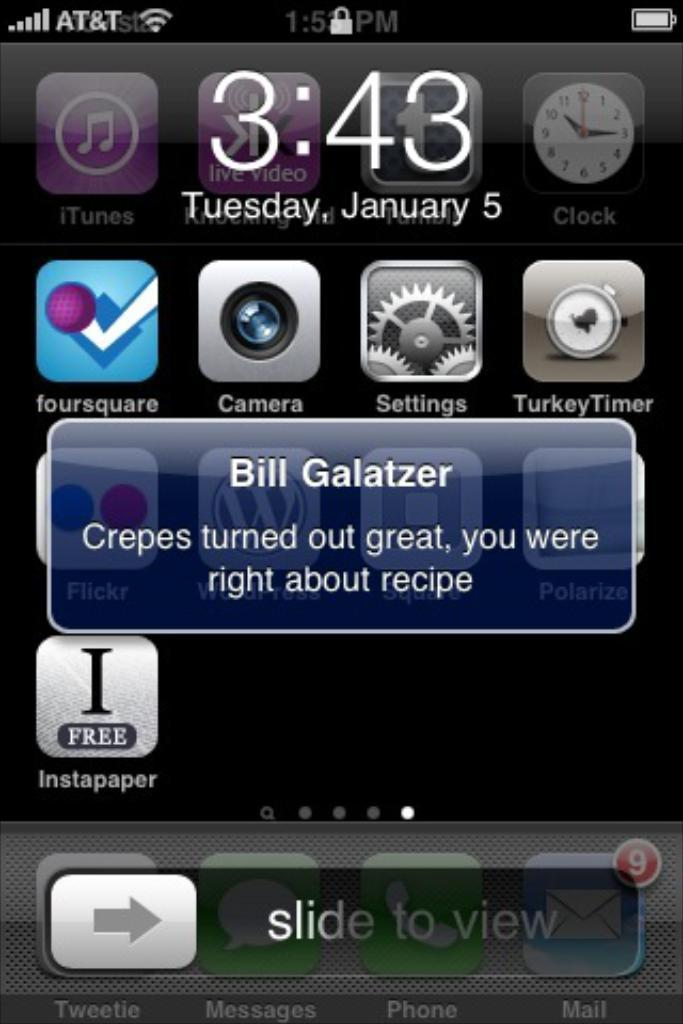<image>
Share a concise interpretation of the image provided. A screen picture of an old IPhone that shows a text sent by Bill Galatzer. 